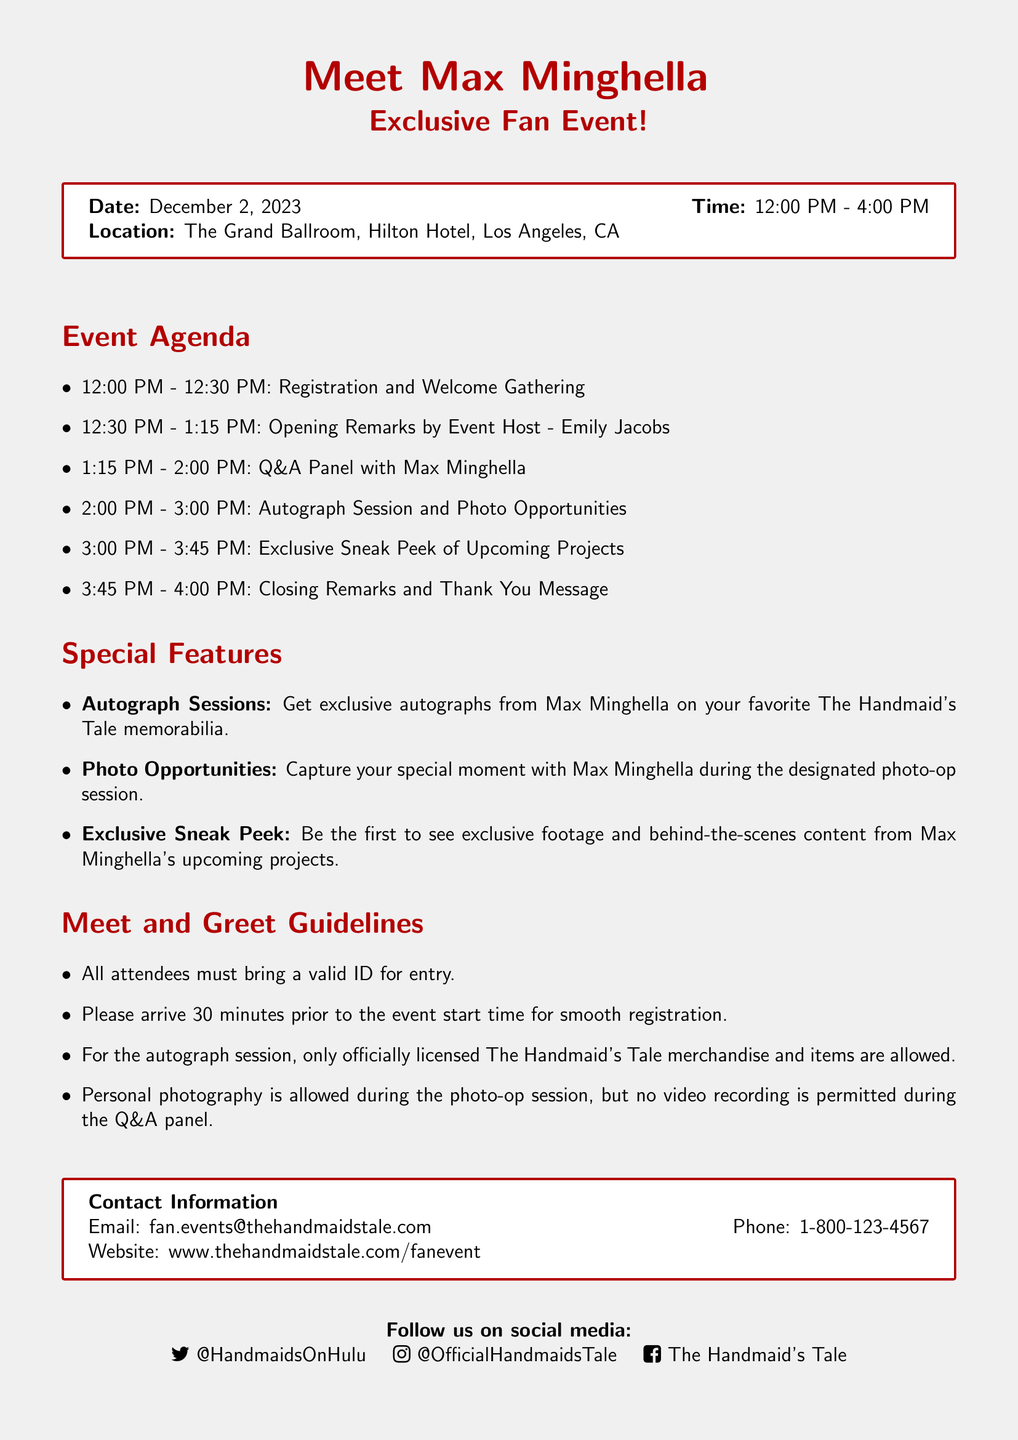What is the date of the event? The date of the event is specified in the document as December 2, 2023.
Answer: December 2, 2023 What time does the event start? The start time of the event is mentioned in the document, which is 12:00 PM.
Answer: 12:00 PM Where is the event being held? The location of the event is given in the document as The Grand Ballroom, Hilton Hotel, Los Angeles, CA.
Answer: The Grand Ballroom, Hilton Hotel, Los Angeles, CA Who will host the opening remarks? The document states that the event host for the opening remarks is Emily Jacobs.
Answer: Emily Jacobs What happens at 2:00 PM? The document lists the activities in the event agenda, and at 2:00 PM, there is an autograph session and photo opportunities.
Answer: Autograph Session and Photo Opportunities What items are allowed for autographs? According to the meet and greet guidelines, only officially licensed The Handmaid's Tale merchandise and items are allowed for autographs.
Answer: Officially licensed The Handmaid's Tale merchandise What is the purpose of the Q&A panel? The reason for the Q&A panel, as indicated in the document, is to provide attendees an opportunity to interact and ask questions to Max Minghella.
Answer: Interaction with Max Minghella Is personal photography allowed? The meet and greet guidelines in the document specify that personal photography is allowed during the photo-op session.
Answer: Allowed during the photo-op session How can attendees contact for more information? The document provides contact information including an email and phone number for inquiries: fan.events@thehandmaidstale.com and 1-800-123-4567.
Answer: fan.events@thehandmaidstale.com and 1-800-123-4567 